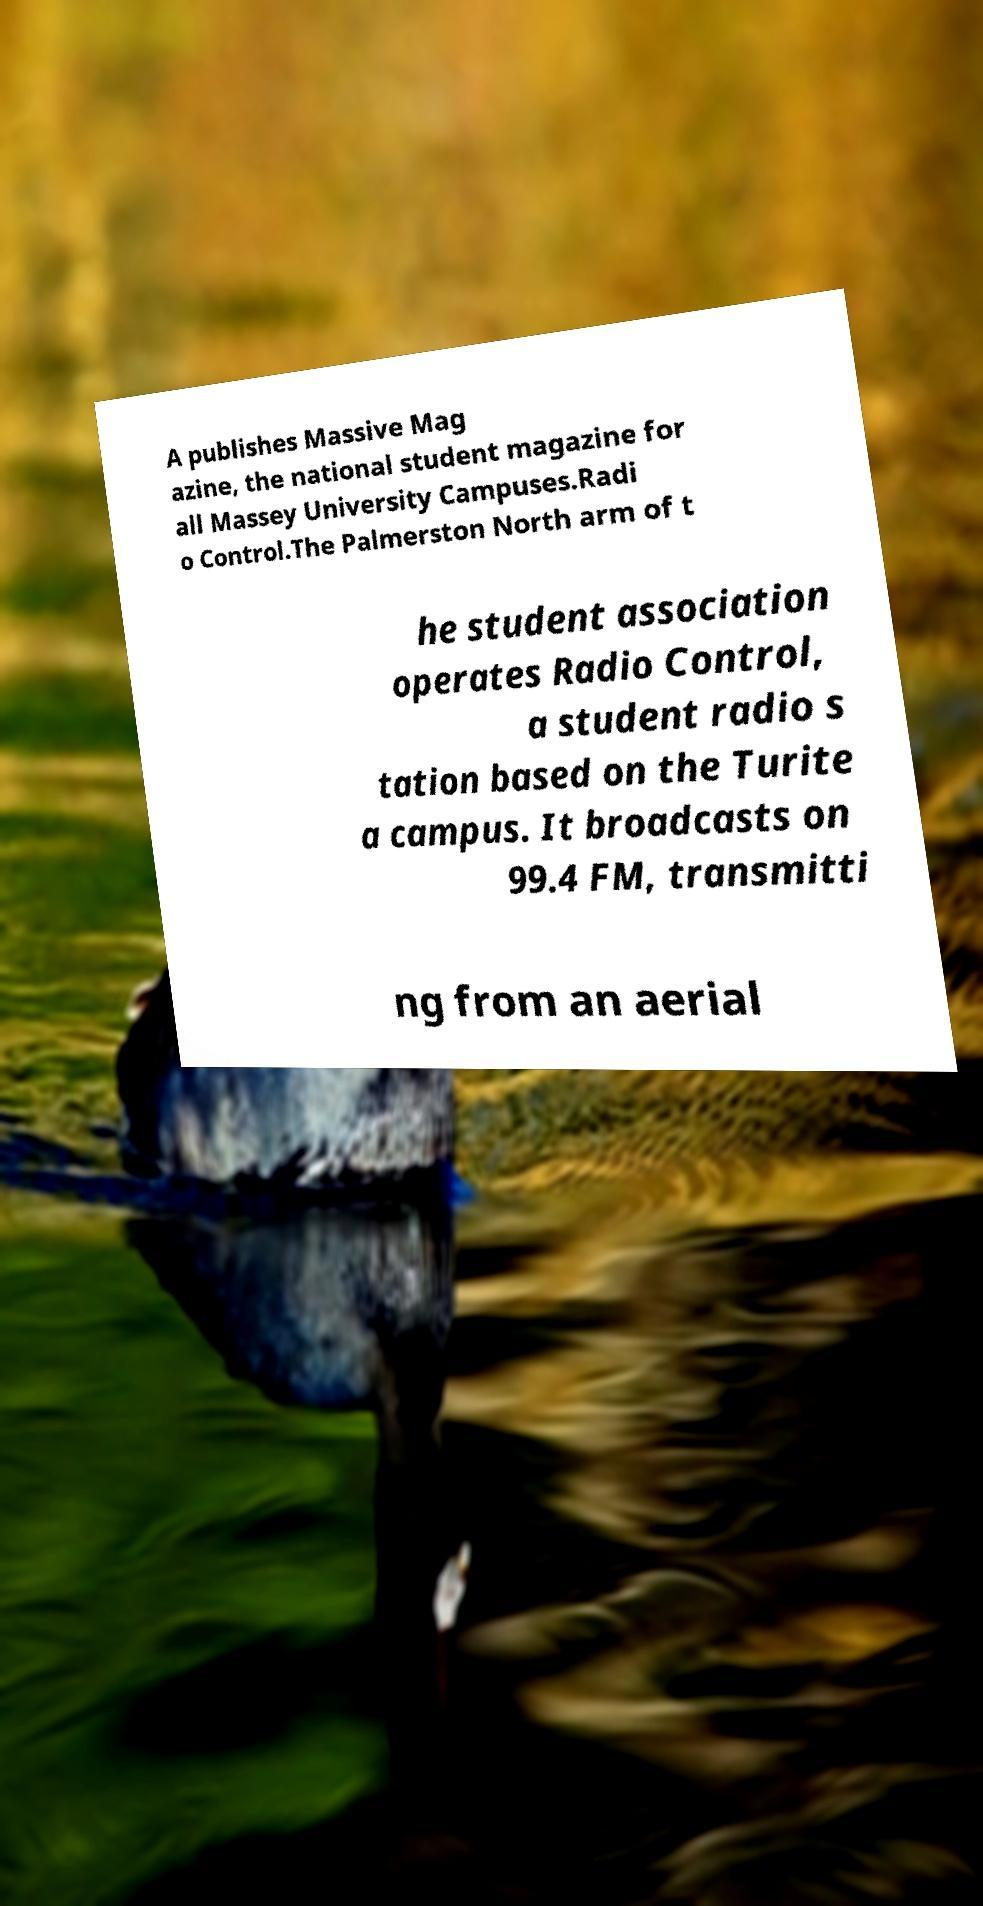Please identify and transcribe the text found in this image. A publishes Massive Mag azine, the national student magazine for all Massey University Campuses.Radi o Control.The Palmerston North arm of t he student association operates Radio Control, a student radio s tation based on the Turite a campus. It broadcasts on 99.4 FM, transmitti ng from an aerial 